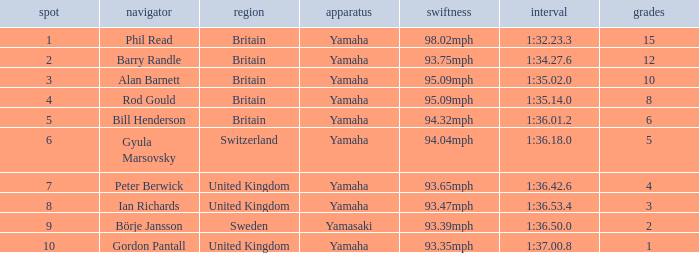What was the time for the man who scored 1 point? 1:37.00.8. 